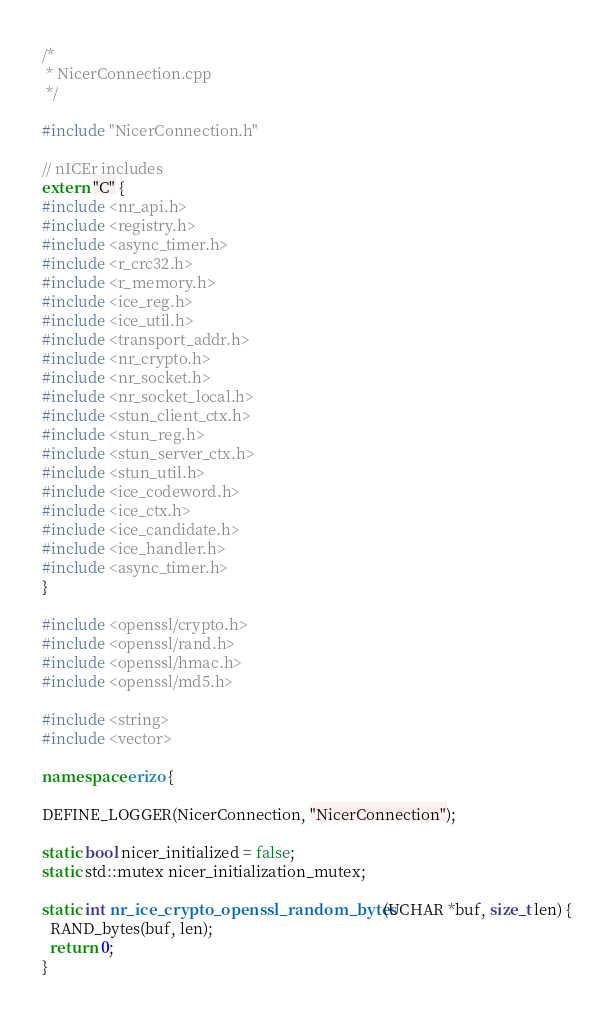<code> <loc_0><loc_0><loc_500><loc_500><_C++_>/*
 * NicerConnection.cpp
 */

#include "NicerConnection.h"

// nICEr includes
extern "C" {
#include <nr_api.h>
#include <registry.h>
#include <async_timer.h>
#include <r_crc32.h>
#include <r_memory.h>
#include <ice_reg.h>
#include <ice_util.h>
#include <transport_addr.h>
#include <nr_crypto.h>
#include <nr_socket.h>
#include <nr_socket_local.h>
#include <stun_client_ctx.h>
#include <stun_reg.h>
#include <stun_server_ctx.h>
#include <stun_util.h>
#include <ice_codeword.h>
#include <ice_ctx.h>
#include <ice_candidate.h>
#include <ice_handler.h>
#include <async_timer.h>
}

#include <openssl/crypto.h>
#include <openssl/rand.h>
#include <openssl/hmac.h>
#include <openssl/md5.h>

#include <string>
#include <vector>

namespace erizo {

DEFINE_LOGGER(NicerConnection, "NicerConnection");

static bool nicer_initialized = false;
static std::mutex nicer_initialization_mutex;

static int nr_ice_crypto_openssl_random_bytes(UCHAR *buf, size_t len) {
  RAND_bytes(buf, len);
  return 0;
}
</code> 